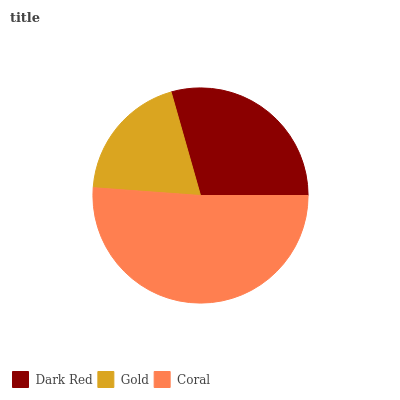Is Gold the minimum?
Answer yes or no. Yes. Is Coral the maximum?
Answer yes or no. Yes. Is Coral the minimum?
Answer yes or no. No. Is Gold the maximum?
Answer yes or no. No. Is Coral greater than Gold?
Answer yes or no. Yes. Is Gold less than Coral?
Answer yes or no. Yes. Is Gold greater than Coral?
Answer yes or no. No. Is Coral less than Gold?
Answer yes or no. No. Is Dark Red the high median?
Answer yes or no. Yes. Is Dark Red the low median?
Answer yes or no. Yes. Is Gold the high median?
Answer yes or no. No. Is Coral the low median?
Answer yes or no. No. 